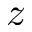<formula> <loc_0><loc_0><loc_500><loc_500>z</formula> 